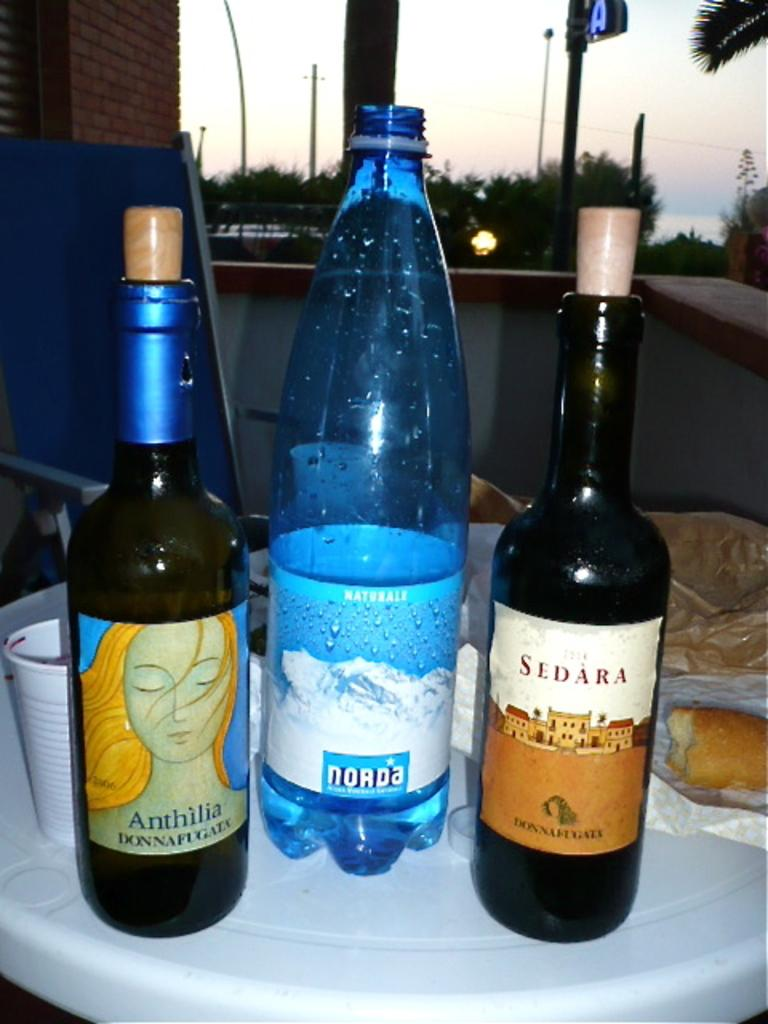<image>
Create a compact narrative representing the image presented. Bottles of wine from the brands Anthilia and Sedara sit on a table next to a bottle of Norda water. 